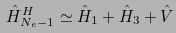Convert formula to latex. <formula><loc_0><loc_0><loc_500><loc_500>\hat { H } ^ { H } _ { N _ { e } - 1 } \simeq \hat { H } _ { 1 } + \hat { H } _ { 3 } + \hat { V }</formula> 